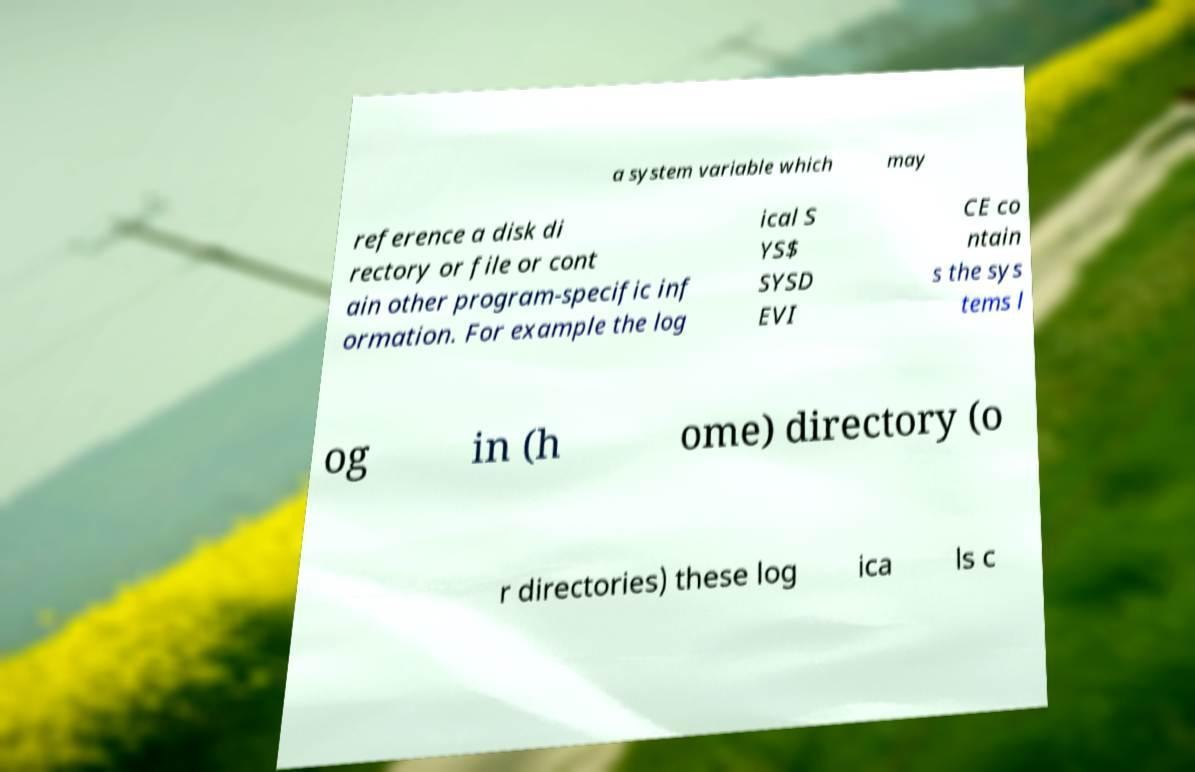Can you accurately transcribe the text from the provided image for me? a system variable which may reference a disk di rectory or file or cont ain other program-specific inf ormation. For example the log ical S YS$ SYSD EVI CE co ntain s the sys tems l og in (h ome) directory (o r directories) these log ica ls c 